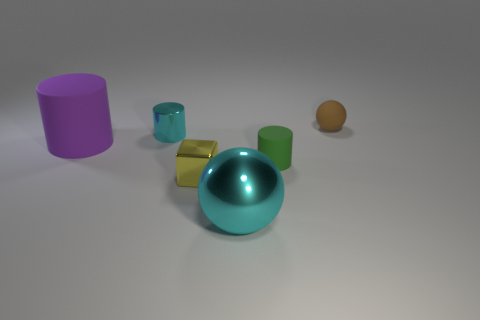Subtract all large cylinders. How many cylinders are left? 2 Subtract all purple cylinders. How many cylinders are left? 2 Add 2 large purple things. How many objects exist? 8 Subtract all balls. How many objects are left? 4 Subtract 0 gray spheres. How many objects are left? 6 Subtract all cyan blocks. Subtract all cyan cylinders. How many blocks are left? 1 Subtract all small cyan objects. Subtract all big rubber objects. How many objects are left? 4 Add 2 green rubber cylinders. How many green rubber cylinders are left? 3 Add 1 rubber balls. How many rubber balls exist? 2 